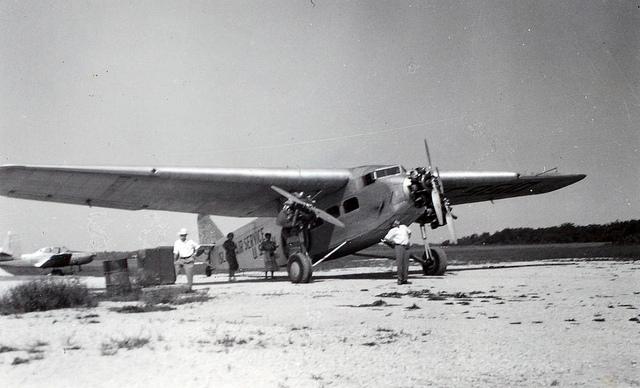Is this a new plane?
Quick response, please. No. Did the plane just land in the desert?
Answer briefly. Yes. Is this in black and white?
Short answer required. Yes. 